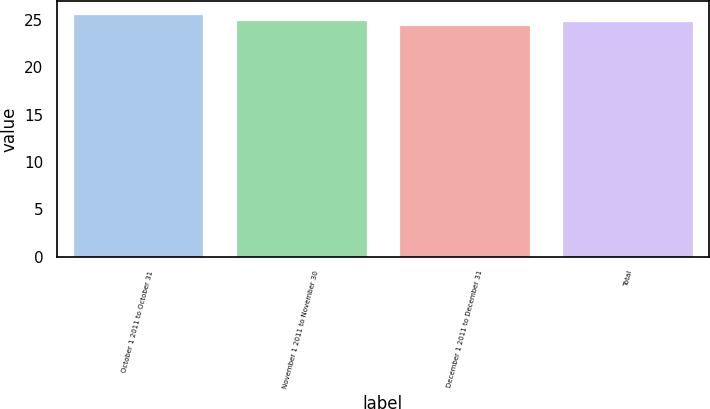<chart> <loc_0><loc_0><loc_500><loc_500><bar_chart><fcel>October 1 2011 to October 31<fcel>November 1 2011 to November 30<fcel>December 1 2011 to December 31<fcel>Total<nl><fcel>25.69<fcel>24.99<fcel>24.45<fcel>24.87<nl></chart> 